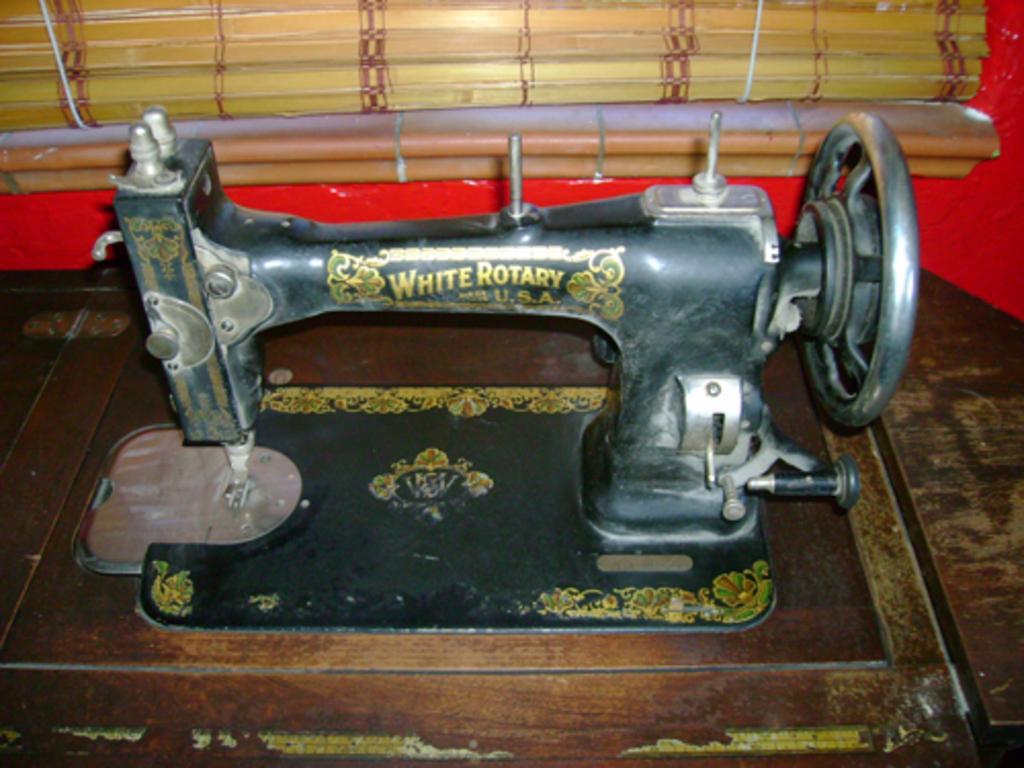In one or two sentences, can you explain what this image depicts? In this image we can see a machine placed on the table. At the top of the image we can see window blinds. 